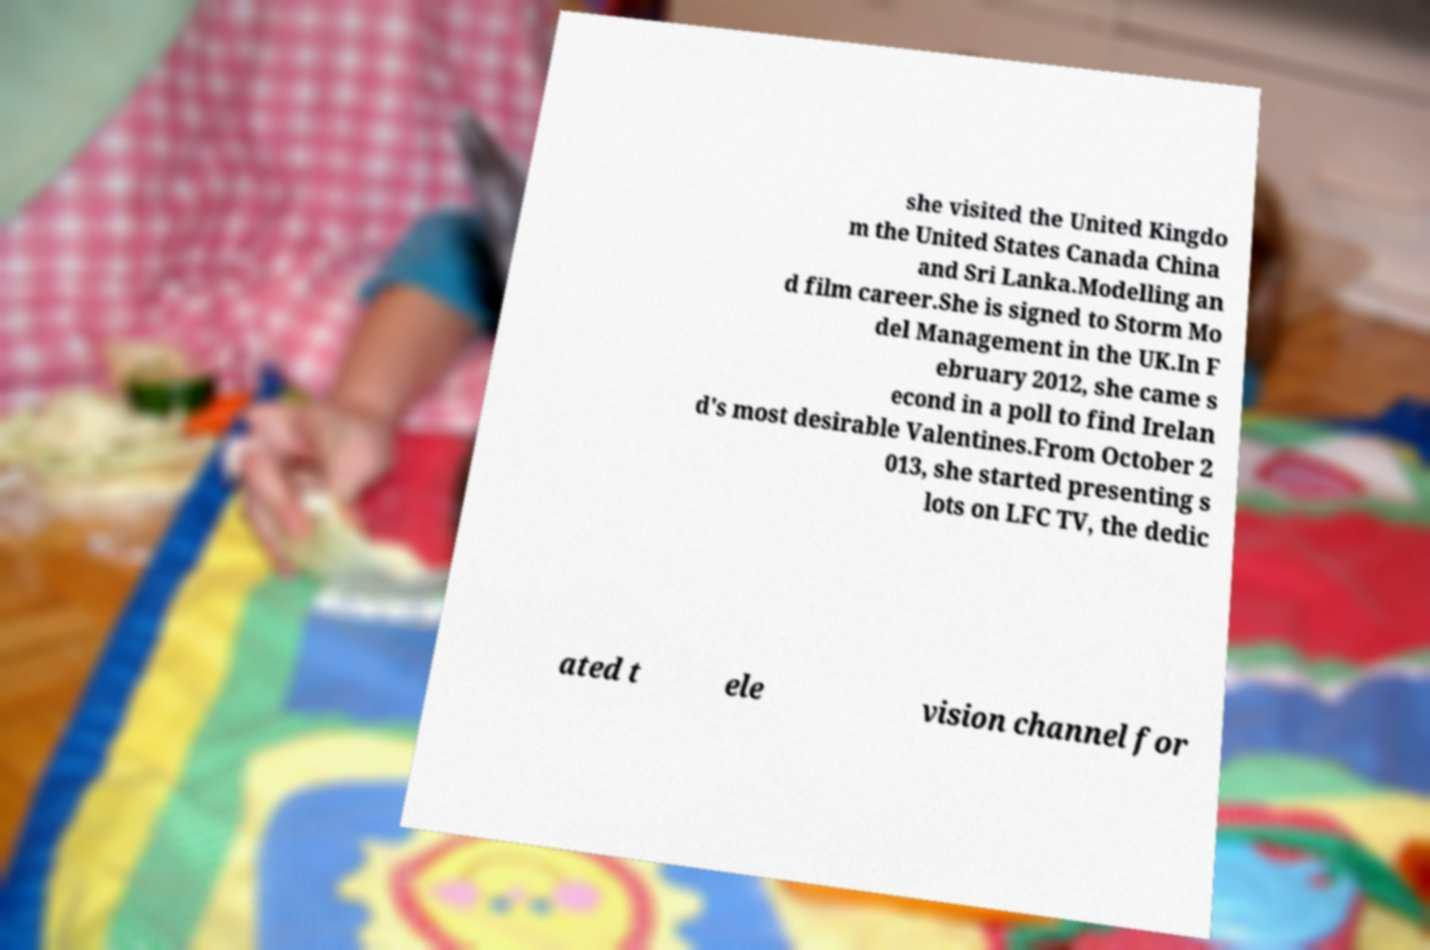What messages or text are displayed in this image? I need them in a readable, typed format. she visited the United Kingdo m the United States Canada China and Sri Lanka.Modelling an d film career.She is signed to Storm Mo del Management in the UK.In F ebruary 2012, she came s econd in a poll to find Irelan d's most desirable Valentines.From October 2 013, she started presenting s lots on LFC TV, the dedic ated t ele vision channel for 